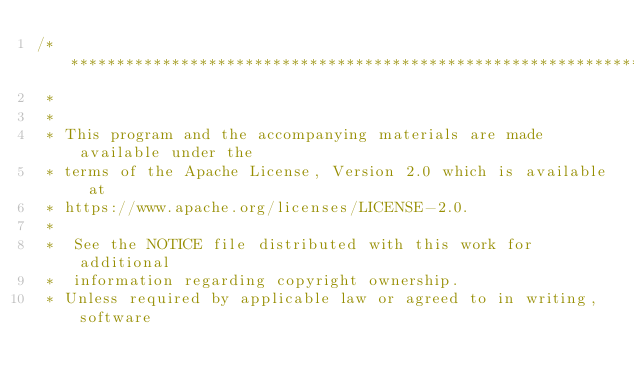<code> <loc_0><loc_0><loc_500><loc_500><_Cuda_>/* ******************************************************************************
 *
 *
 * This program and the accompanying materials are made available under the
 * terms of the Apache License, Version 2.0 which is available at
 * https://www.apache.org/licenses/LICENSE-2.0.
 *
 *  See the NOTICE file distributed with this work for additional
 *  information regarding copyright ownership.
 * Unless required by applicable law or agreed to in writing, software</code> 